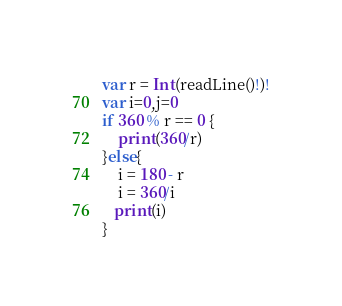Convert code to text. <code><loc_0><loc_0><loc_500><loc_500><_Swift_>var r = Int(readLine()!)!
var i=0,j=0
if 360 % r == 0 {
    print(360/r)
}else{
    i = 180 - r
    i = 360/i
   print(i)
}</code> 